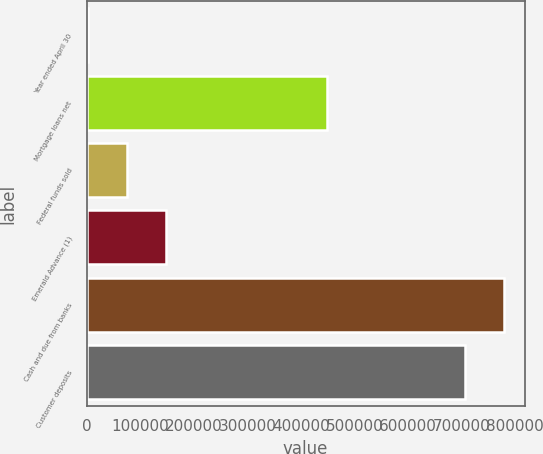Convert chart to OTSL. <chart><loc_0><loc_0><loc_500><loc_500><bar_chart><fcel>Year ended April 30<fcel>Mortgage loans net<fcel>Federal funds sold<fcel>Emerald Advance (1)<fcel>Cash and due from banks<fcel>Customer deposits<nl><fcel>2012<fcel>448431<fcel>75027.2<fcel>148042<fcel>778608<fcel>705593<nl></chart> 